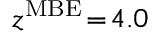Convert formula to latex. <formula><loc_0><loc_0><loc_500><loc_500>z ^ { M B E } \, = \, 4 . 0</formula> 